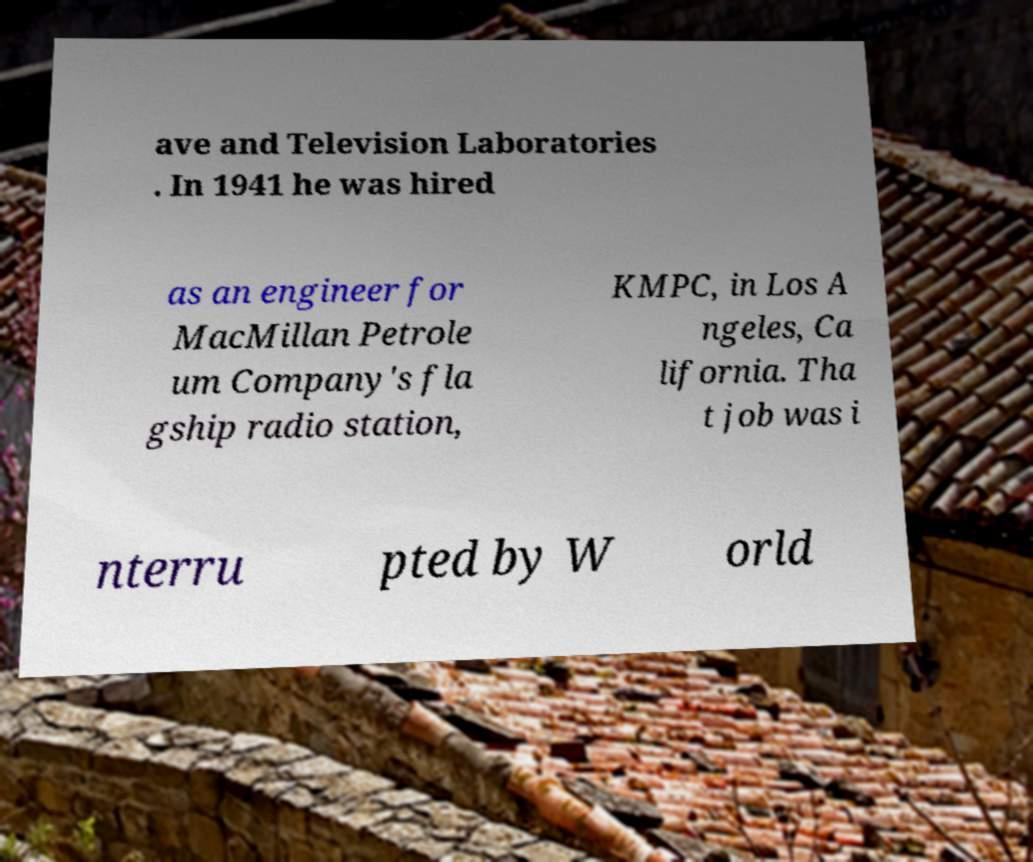What messages or text are displayed in this image? I need them in a readable, typed format. ave and Television Laboratories . In 1941 he was hired as an engineer for MacMillan Petrole um Company's fla gship radio station, KMPC, in Los A ngeles, Ca lifornia. Tha t job was i nterru pted by W orld 